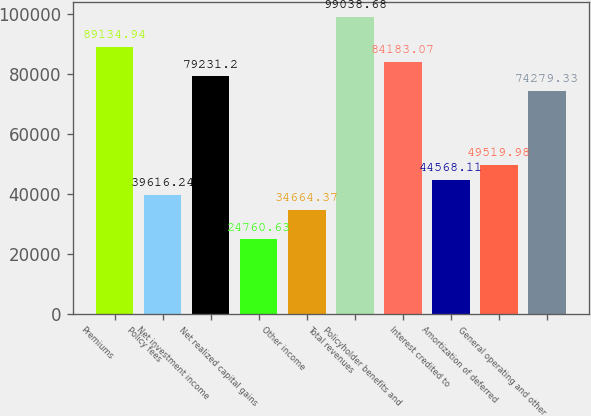Convert chart. <chart><loc_0><loc_0><loc_500><loc_500><bar_chart><fcel>Premiums<fcel>Policy fees<fcel>Net investment income<fcel>Net realized capital gains<fcel>Other income<fcel>Total revenues<fcel>Policyholder benefits and<fcel>Interest credited to<fcel>Amortization of deferred<fcel>General operating and other<nl><fcel>89134.9<fcel>39616.2<fcel>79231.2<fcel>24760.6<fcel>34664.4<fcel>99038.7<fcel>84183.1<fcel>44568.1<fcel>49520<fcel>74279.3<nl></chart> 